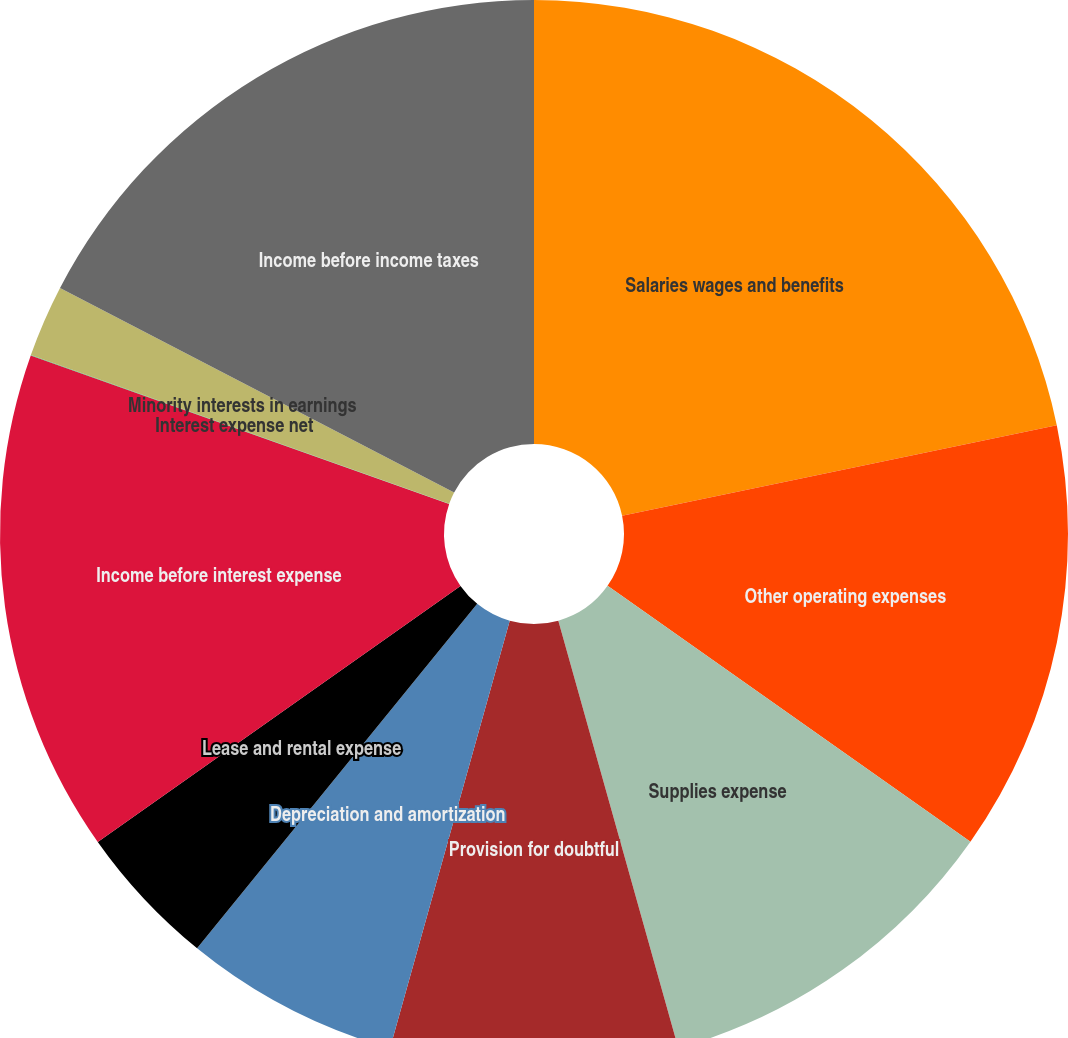Convert chart. <chart><loc_0><loc_0><loc_500><loc_500><pie_chart><fcel>Salaries wages and benefits<fcel>Other operating expenses<fcel>Supplies expense<fcel>Provision for doubtful<fcel>Depreciation and amortization<fcel>Lease and rental expense<fcel>Income before interest expense<fcel>Interest expense net<fcel>Minority interests in earnings<fcel>Income before income taxes<nl><fcel>21.73%<fcel>13.04%<fcel>10.87%<fcel>8.7%<fcel>6.52%<fcel>4.35%<fcel>15.21%<fcel>0.01%<fcel>2.18%<fcel>17.38%<nl></chart> 